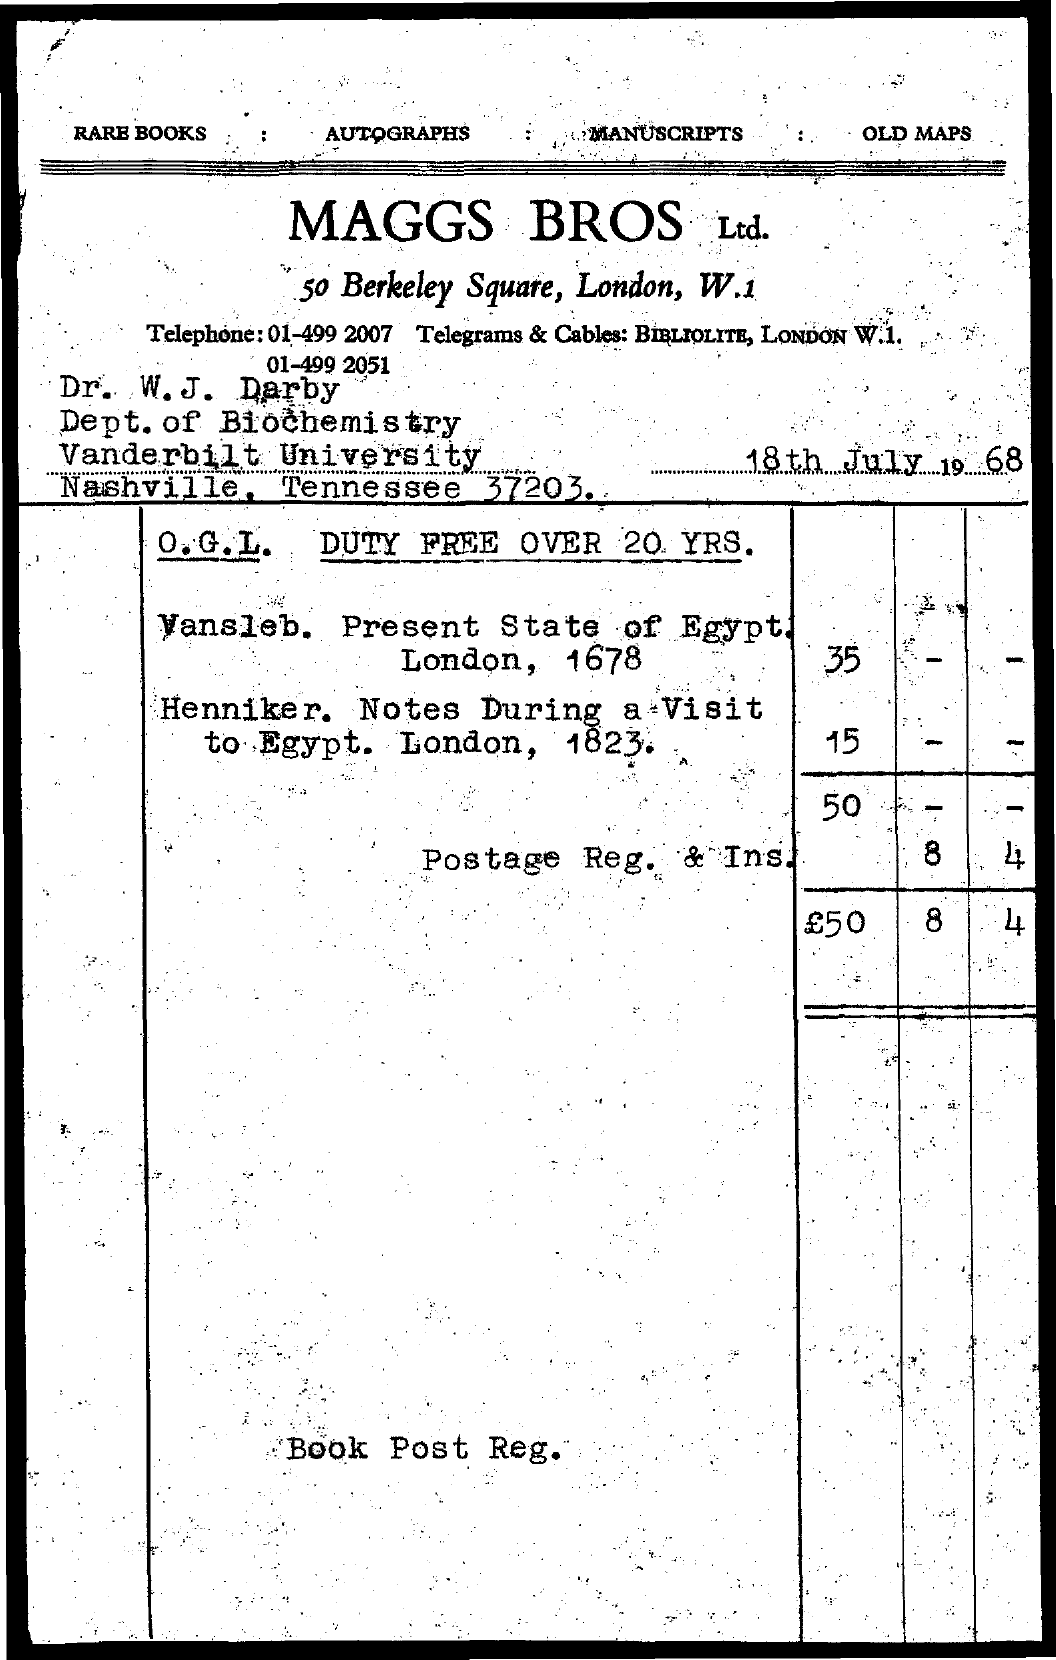Specify some key components in this picture. William J. Darby is affiliated with Vanderbilt University. William J. Darby is affiliated with the department of biochemistry. The text "Old Maps..." is located at the top-right. The date mentioned in the document is 18th July 1968. 